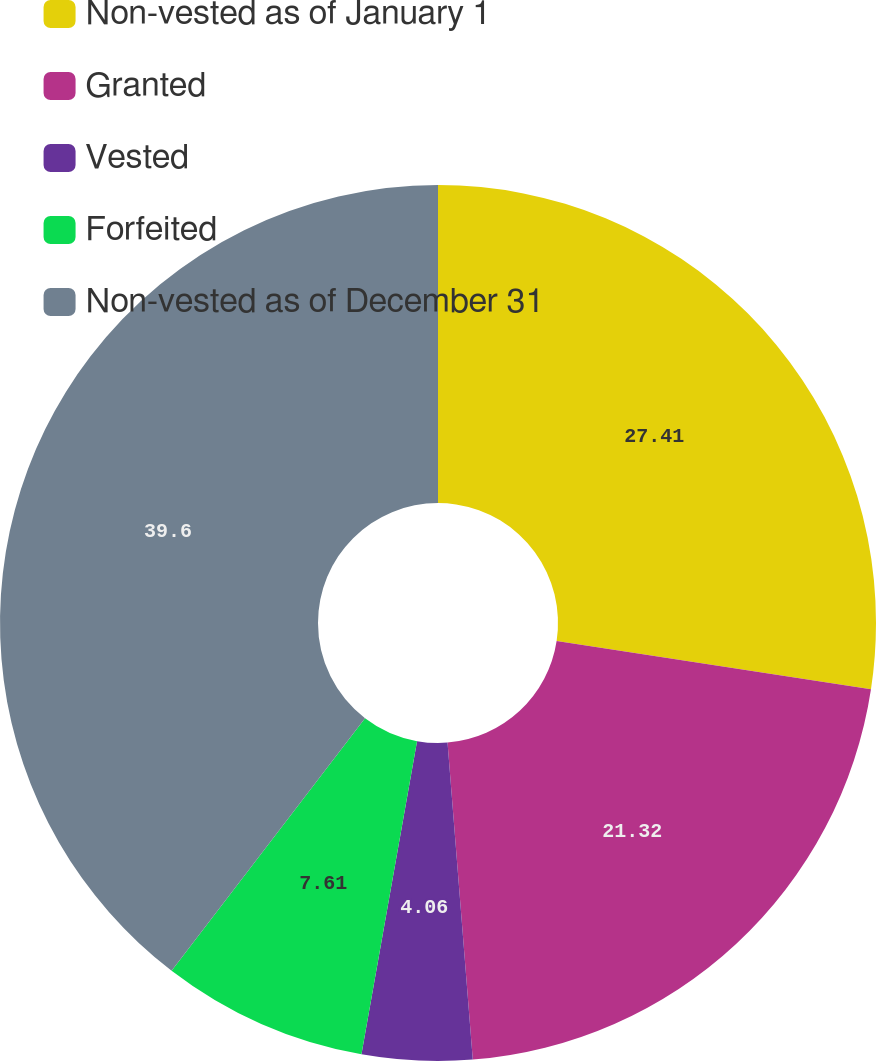<chart> <loc_0><loc_0><loc_500><loc_500><pie_chart><fcel>Non-vested as of January 1<fcel>Granted<fcel>Vested<fcel>Forfeited<fcel>Non-vested as of December 31<nl><fcel>27.41%<fcel>21.32%<fcel>4.06%<fcel>7.61%<fcel>39.59%<nl></chart> 